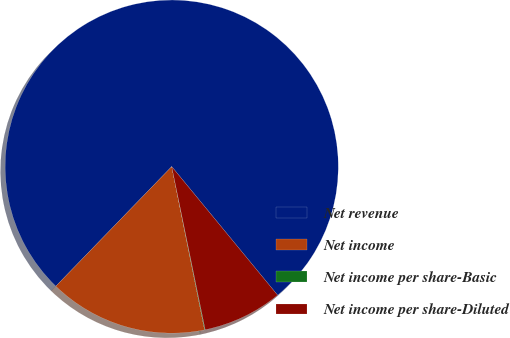Convert chart to OTSL. <chart><loc_0><loc_0><loc_500><loc_500><pie_chart><fcel>Net revenue<fcel>Net income<fcel>Net income per share-Basic<fcel>Net income per share-Diluted<nl><fcel>76.79%<fcel>15.41%<fcel>0.06%<fcel>7.74%<nl></chart> 